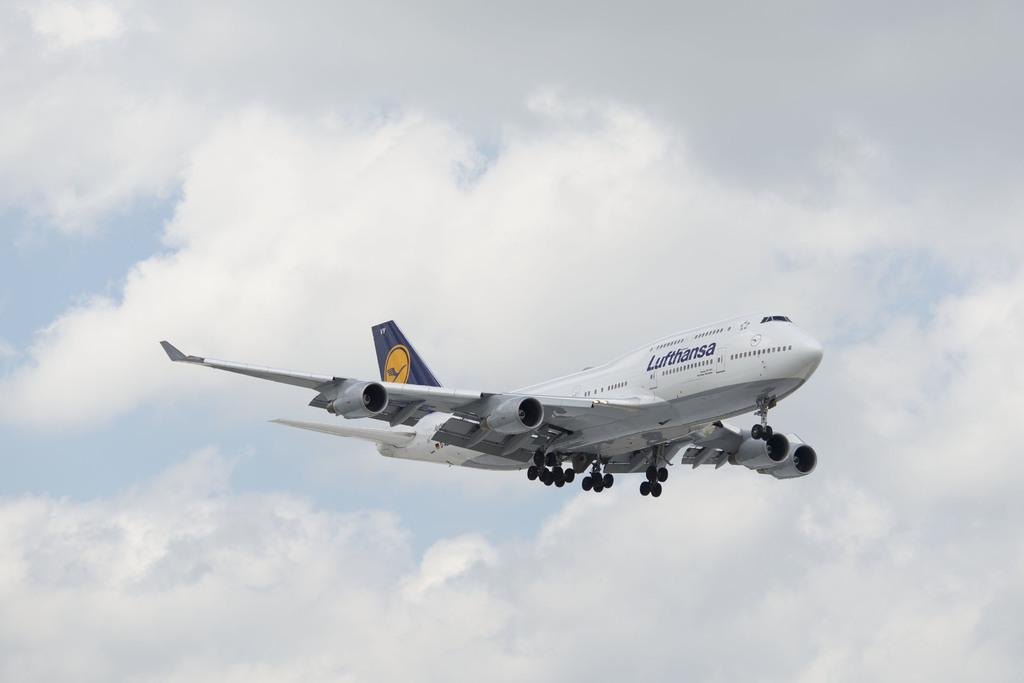What is the main subject of the image? The main subject of the image is an airplane. Where is the airplane located in the image? The airplane is in the air in the image. What can be seen in the background of the image? The sky is visible in the image. How would you describe the weather based on the image? The sky is clear in the image, suggesting good weather. How does the airplane start the pump in the image? There is no pump present in the image, and the airplane is not shown performing any actions related to a pump. 